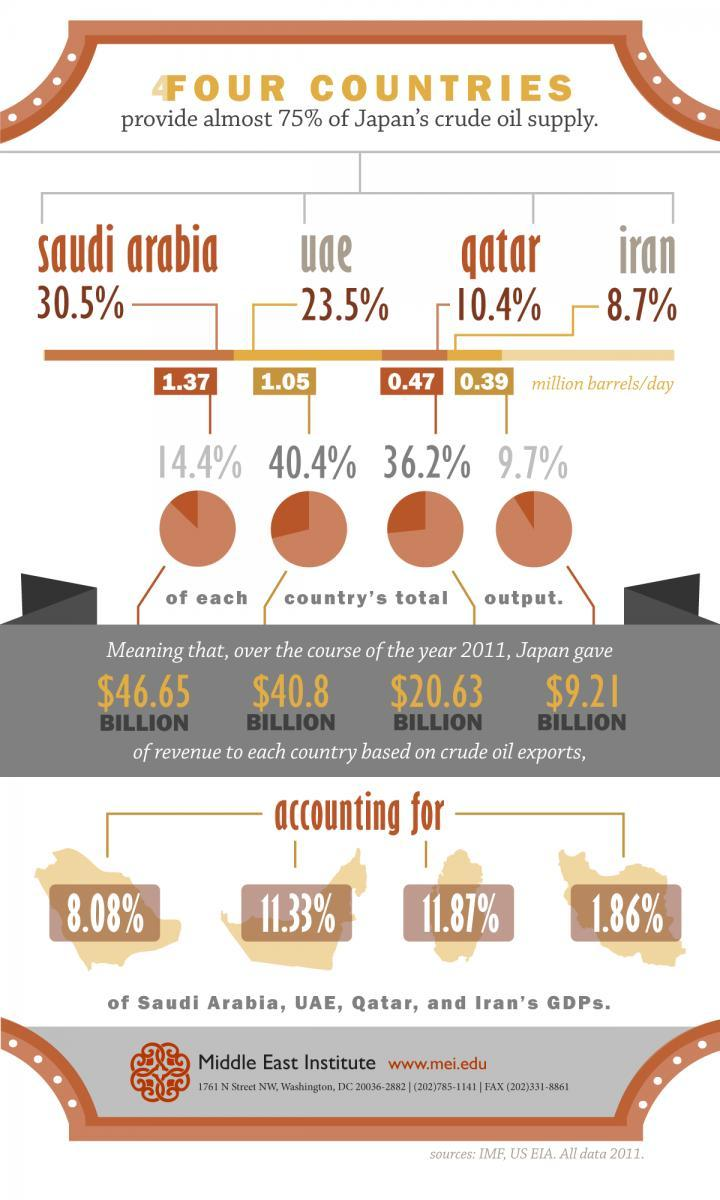How many million barrels per day of crude oil supply were exported to Japan by Iran in 2011?
Answer the question with a short phrase. 0.39 What amount of revenue (in billions) did Iran receive from Japan based on crude oil exports during 2011? $9.21 What amount of revenue (in billions) did Qatar receive from Japan based on crude oil exports during 2011? $20.63 Which country provided 10.4% of  japan's crude oil supply in 2011? qatar What percent of UAE's GDP was contributed by crude oil exports to Japan in 2011? 11.33% What percent of Qatar's GDP was contributed by crude oil exports to Japan in 2011? 11.87% What amount of revenue (in billions) did UAE receive from Japan based on crude oil exports during 2011? $40.8 Which country provided 23.5% of japan's crude oil supply in 2011? uae What percent of Saudi Arabia's GDP was contributed by crude oil exports to Japan in 2011? 8.08% 